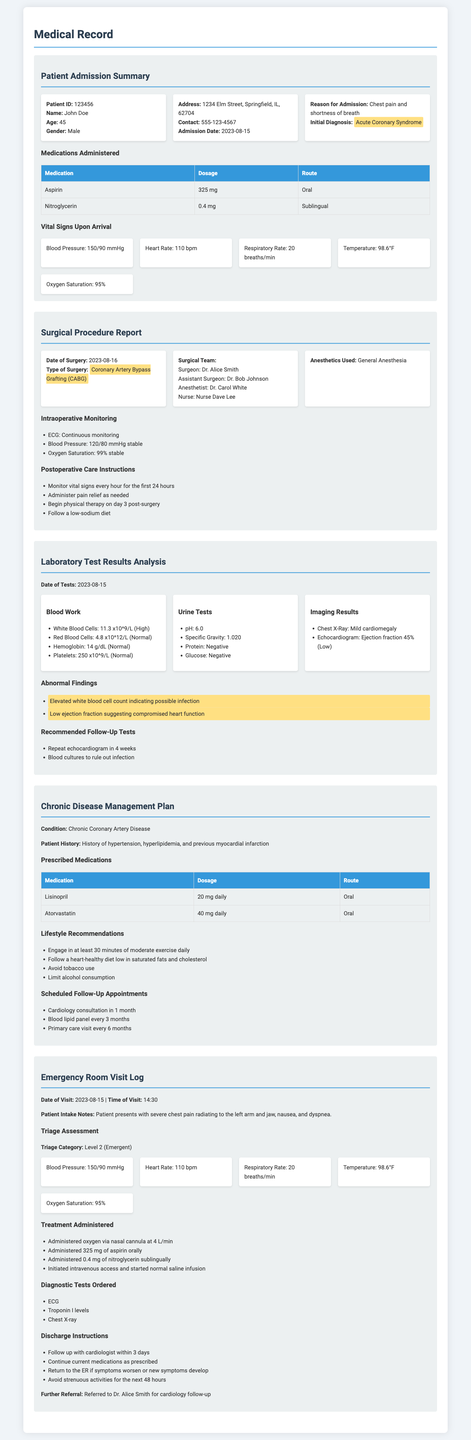What is the patient ID? The patient ID is listed in the Patient Admission Summary section.
Answer: 123456 What was the initial diagnosis? The initial diagnosis is indicated alongside the reason for admission.
Answer: Acute Coronary Syndrome Who was the anesthetist during the surgery? The anesthetist's name is part of the Surgical Team section.
Answer: Dr. Carol White What medications were administered upon admission? The medications are provided in a table under the Patient Admission Summary section.
Answer: Aspirin and Nitroglycerin What is the prescribed dosage of Lisinopril? The dosage for Lisinopril is detailed in the Chronic Disease Management Plan section.
Answer: 20 mg daily What follow-up tests are recommended after the lab results? The follow-up tests are specified in the Laboratory Test Results Analysis section.
Answer: Repeat echocardiogram in 4 weeks and Blood cultures What was the triage category during the ER visit? The triage category is mentioned in the Emergency Room Visit Log.
Answer: Level 2 (Emergent) When did the surgical procedure take place? The date of the surgery is recorded in the Surgical Procedure Report section.
Answer: 2023-08-16 What is the oxygen saturation recorded upon arrival? The oxygen saturation is part of vital signs in the Patient Admission Summary.
Answer: 95% 